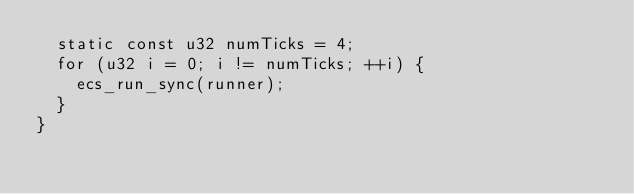<code> <loc_0><loc_0><loc_500><loc_500><_C_>  static const u32 numTicks = 4;
  for (u32 i = 0; i != numTicks; ++i) {
    ecs_run_sync(runner);
  }
}
</code> 